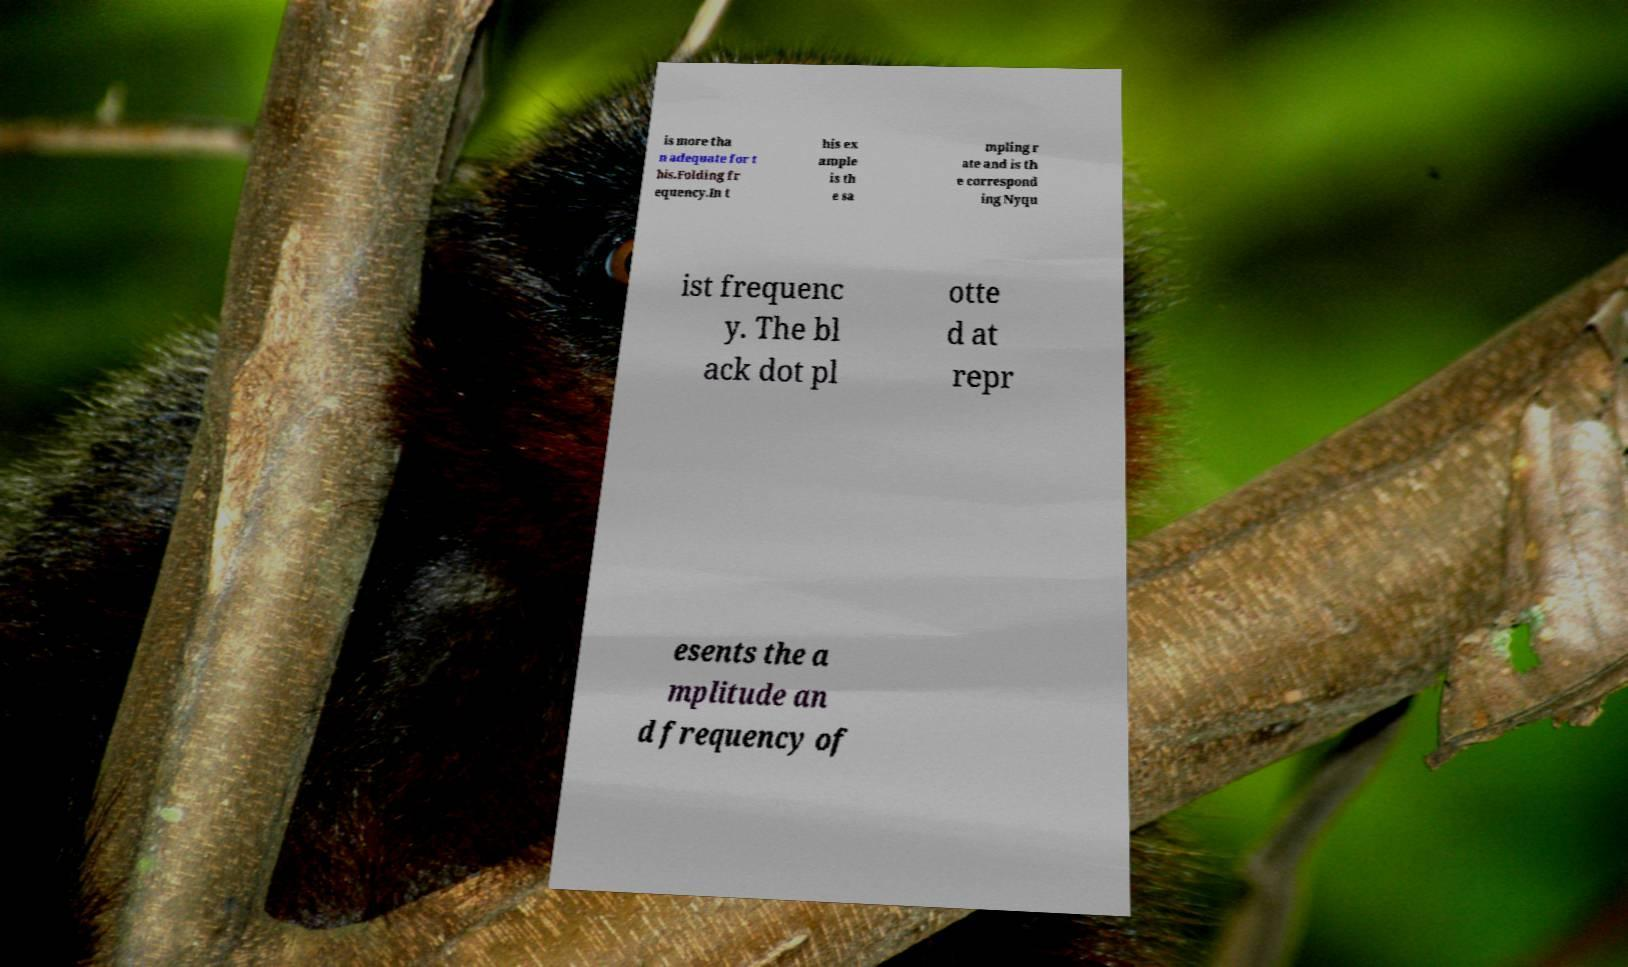There's text embedded in this image that I need extracted. Can you transcribe it verbatim? is more tha n adequate for t his.Folding fr equency.In t his ex ample is th e sa mpling r ate and is th e correspond ing Nyqu ist frequenc y. The bl ack dot pl otte d at repr esents the a mplitude an d frequency of 